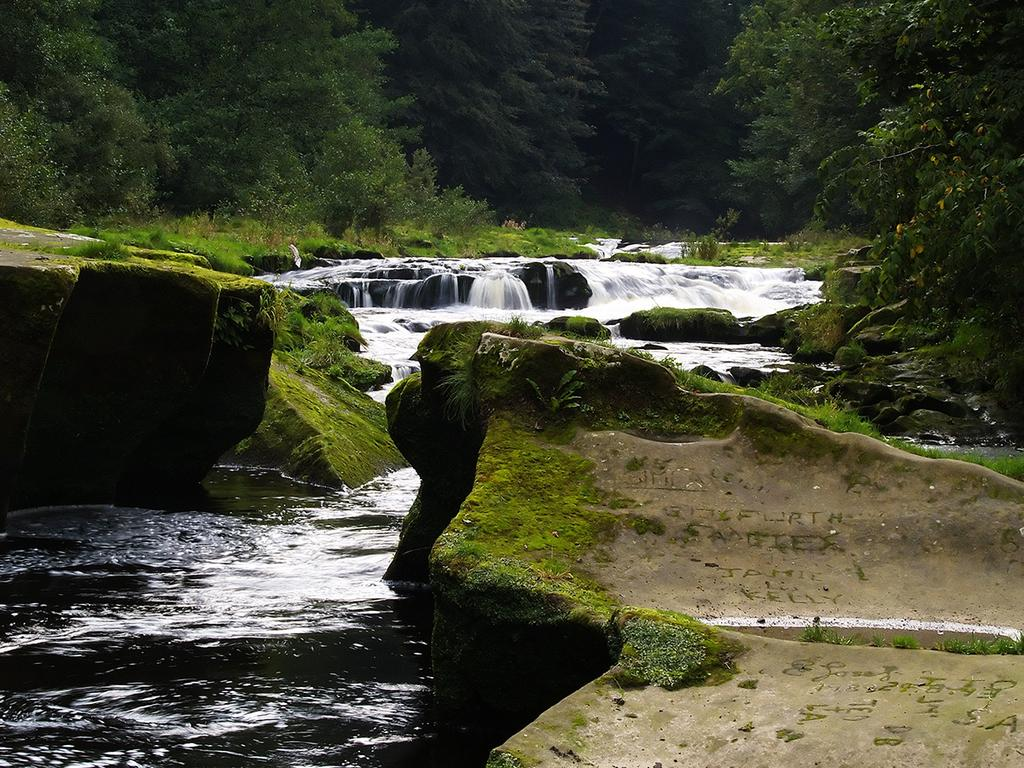What type of water feature is present in the image? There is a tributary of a river flowing in the image. What can be seen near the tributary? There are rocks beside the tributary. What type of vegetation is visible in the background of the image? There are trees in the background of the image. What type of advice can be seen written on the rocks in the image? There is no advice written on the rocks in the image; the rocks are simply rocks beside the tributary. 